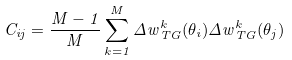<formula> <loc_0><loc_0><loc_500><loc_500>C _ { i j } = \frac { M - 1 } { M } \sum _ { k = 1 } ^ { M } { \Delta { w } } _ { T G } ^ { k } ( \theta _ { i } ) { \Delta { w } } _ { T G } ^ { k } ( \theta _ { j } )</formula> 